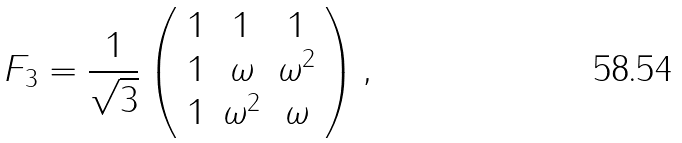Convert formula to latex. <formula><loc_0><loc_0><loc_500><loc_500>F _ { 3 } = \frac { 1 } { \sqrt { 3 } } \left ( \begin{array} { c c c } 1 & 1 & 1 \\ 1 & \omega & \omega ^ { 2 } \\ 1 & \omega ^ { 2 } & \omega \end{array} \right ) ,</formula> 